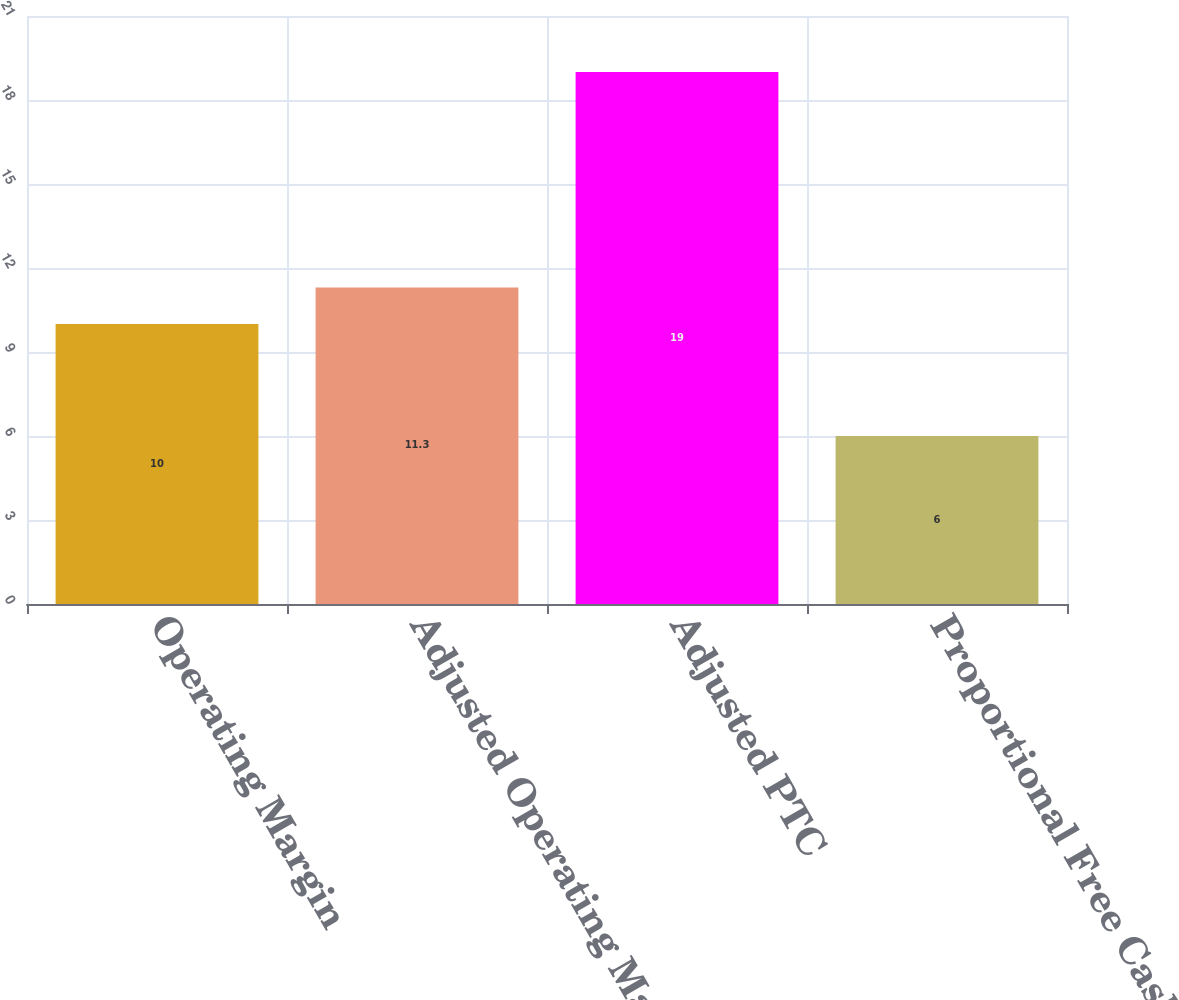Convert chart. <chart><loc_0><loc_0><loc_500><loc_500><bar_chart><fcel>Operating Margin<fcel>Adjusted Operating Margin<fcel>Adjusted PTC<fcel>Proportional Free Cash Flow<nl><fcel>10<fcel>11.3<fcel>19<fcel>6<nl></chart> 